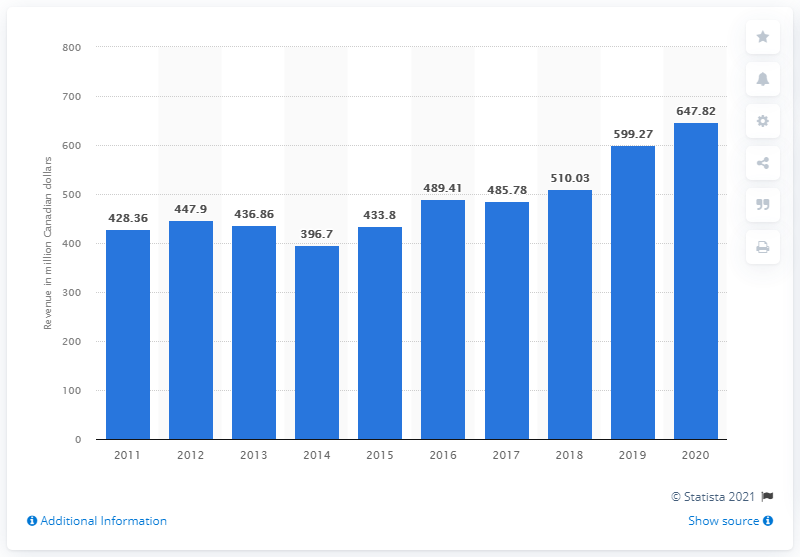Outline some significant characteristics in this image. The total music revenues in Canada in 2020 was $647.82. The total music revenues in Canada from the previous year were 599.27... 